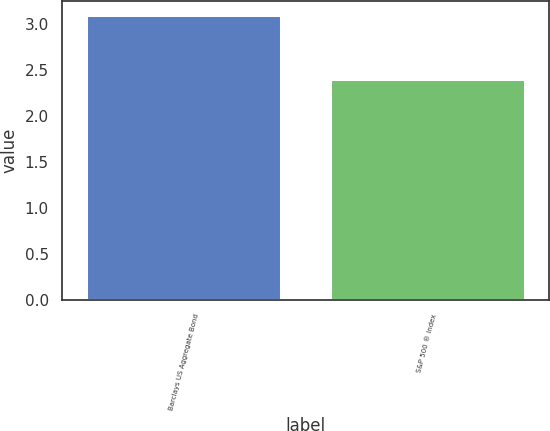<chart> <loc_0><loc_0><loc_500><loc_500><bar_chart><fcel>Barclays US Aggregate Bond<fcel>S&P 500 ® Index<nl><fcel>3.1<fcel>2.4<nl></chart> 